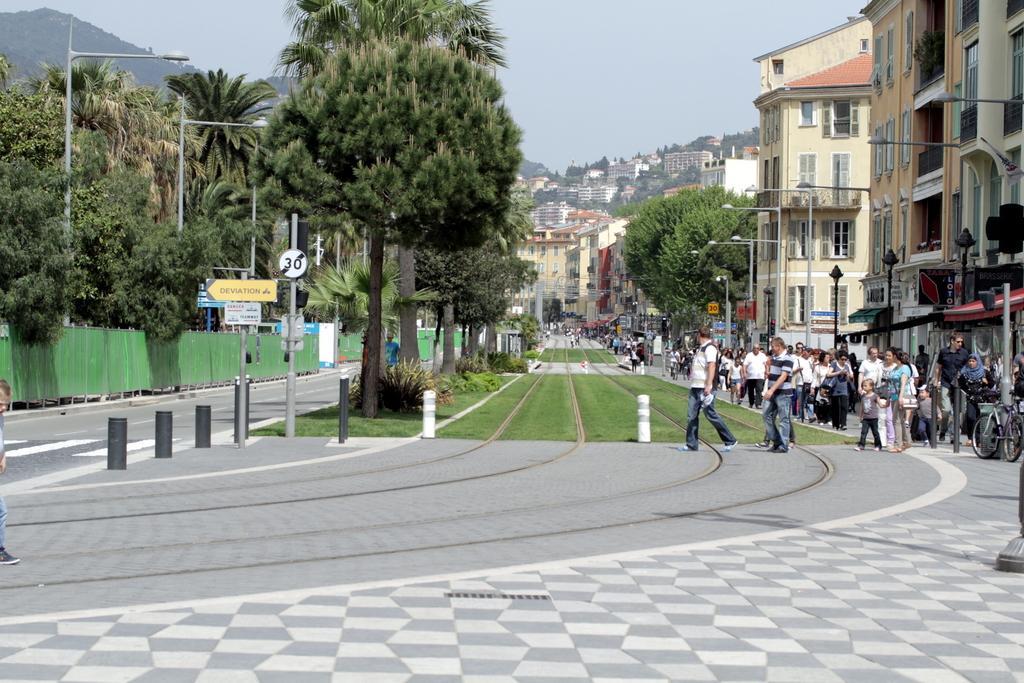In one or two sentences, can you explain what this image depicts? As we can see in the image there is grass, trees, buildings, street lamps, few people here and there, bicycle, plants and there is a sky. 